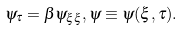<formula> <loc_0><loc_0><loc_500><loc_500>\psi _ { \tau } = \beta \psi _ { \xi \xi } , \psi \equiv \psi ( \xi , \tau ) .</formula> 